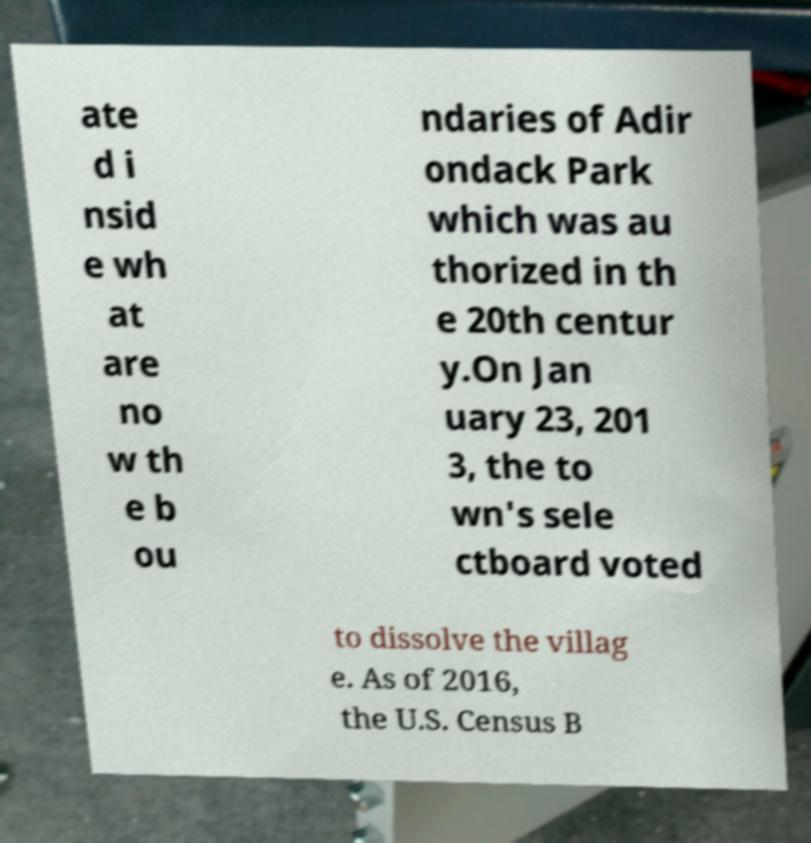There's text embedded in this image that I need extracted. Can you transcribe it verbatim? ate d i nsid e wh at are no w th e b ou ndaries of Adir ondack Park which was au thorized in th e 20th centur y.On Jan uary 23, 201 3, the to wn's sele ctboard voted to dissolve the villag e. As of 2016, the U.S. Census B 